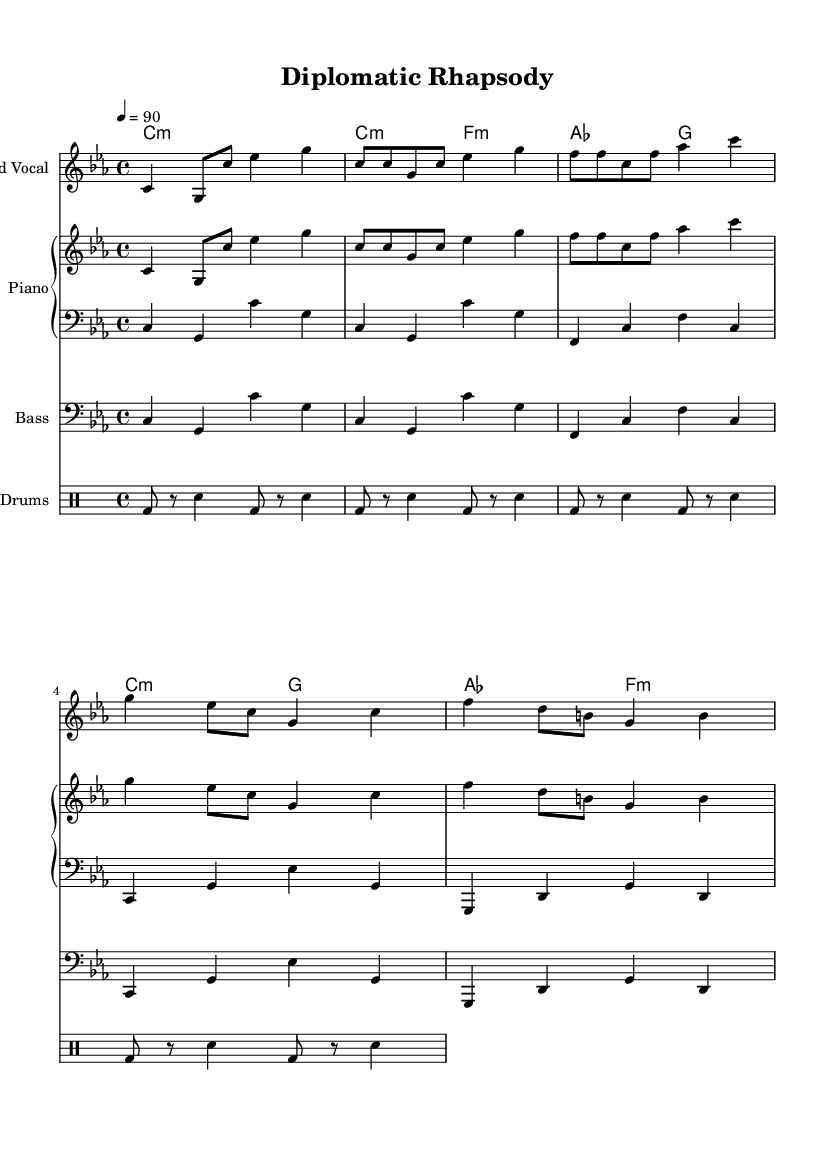What is the key signature of this music? The key signature is C minor, which has three flats (B♭, E♭, A♭).
Answer: C minor What is the time signature of the piece? The time signature is 4/4, indicating four beats in each measure and a quarter note receives one beat.
Answer: 4/4 What is the tempo marking of the piece? The tempo marking is 4 equals 90, meaning there are 90 beats per minute.
Answer: 90 How many lines of lyrics are there in the verse? The verse contains two lines of lyrics: "From London to Beijing, diplomacy's the key" and "Navigating tensions, seeking harmony."
Answer: 2 lines What role does the bass part play in this piece? The bass part provides the harmonic foundation and rhythm that supports the melody and lyrics, typical in hip hop to give a low-frequency backbone to the track.
Answer: Harmonic foundation In what way does the chorus contribute to the overall theme? The chorus "Bridging divides, finding common ground" reinforces the theme of diplomacy and unity, which is central to the song's message about global issues.
Answer: Central theme How does the drum pattern reflect hip hop style? The drum pattern features a repetitive kick and snare that is characteristic of hip hop, creating a steady groove that complements the rhythmic flow of the lyrics.
Answer: Steady groove 